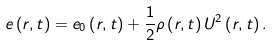<formula> <loc_0><loc_0><loc_500><loc_500>e \left ( r , t \right ) = e _ { 0 } \left ( r , t \right ) + \frac { 1 } { 2 } \rho \left ( r , t \right ) U ^ { 2 } \left ( r , t \right ) .</formula> 